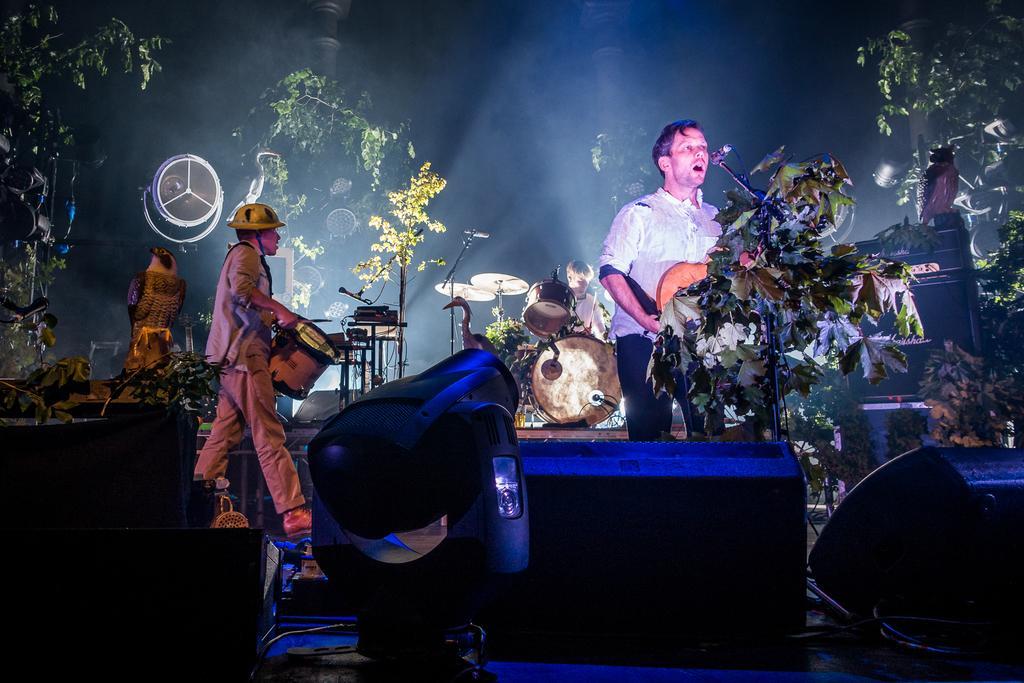How would you summarize this image in a sentence or two? In this image I see 3 men and all of them are with the musical instruments and I can also see that this man over here is standing in front of a mic and there 2 equipment over here. In the background I can see few plants. 